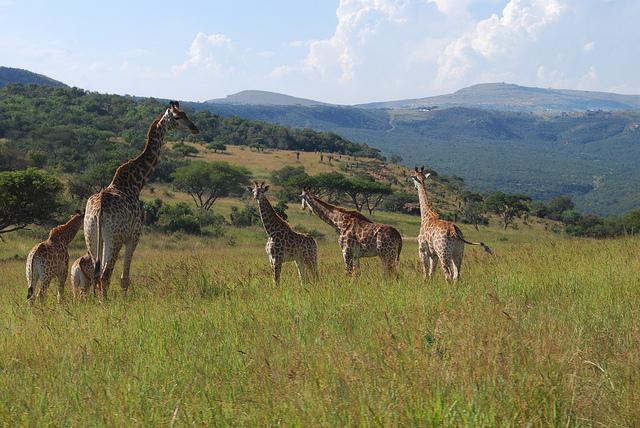How many babies?
Quick response, please. 2. Was this photo taken in the Wild?
Answer briefly. Yes. What type of animal is shown here?
Be succinct. Giraffe. 